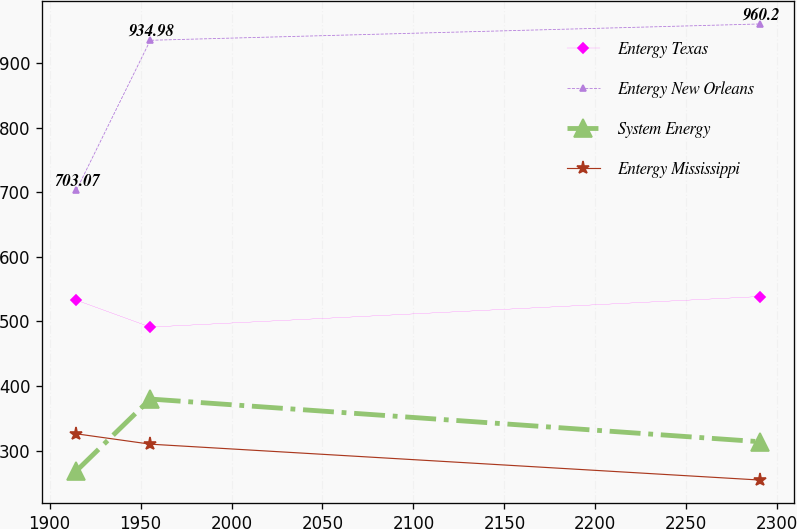<chart> <loc_0><loc_0><loc_500><loc_500><line_chart><ecel><fcel>Entergy Texas<fcel>Entergy New Orleans<fcel>System Energy<fcel>Entergy Mississippi<nl><fcel>1914.74<fcel>532.8<fcel>703.07<fcel>268.59<fcel>325.98<nl><fcel>1955.36<fcel>491.16<fcel>934.98<fcel>379.78<fcel>309.96<nl><fcel>2290.41<fcel>538.44<fcel>960.2<fcel>313.74<fcel>254.45<nl></chart> 